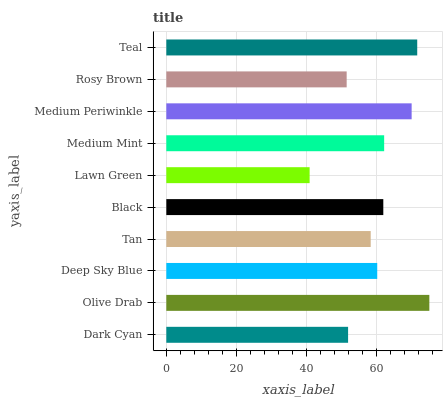Is Lawn Green the minimum?
Answer yes or no. Yes. Is Olive Drab the maximum?
Answer yes or no. Yes. Is Deep Sky Blue the minimum?
Answer yes or no. No. Is Deep Sky Blue the maximum?
Answer yes or no. No. Is Olive Drab greater than Deep Sky Blue?
Answer yes or no. Yes. Is Deep Sky Blue less than Olive Drab?
Answer yes or no. Yes. Is Deep Sky Blue greater than Olive Drab?
Answer yes or no. No. Is Olive Drab less than Deep Sky Blue?
Answer yes or no. No. Is Black the high median?
Answer yes or no. Yes. Is Deep Sky Blue the low median?
Answer yes or no. Yes. Is Dark Cyan the high median?
Answer yes or no. No. Is Rosy Brown the low median?
Answer yes or no. No. 